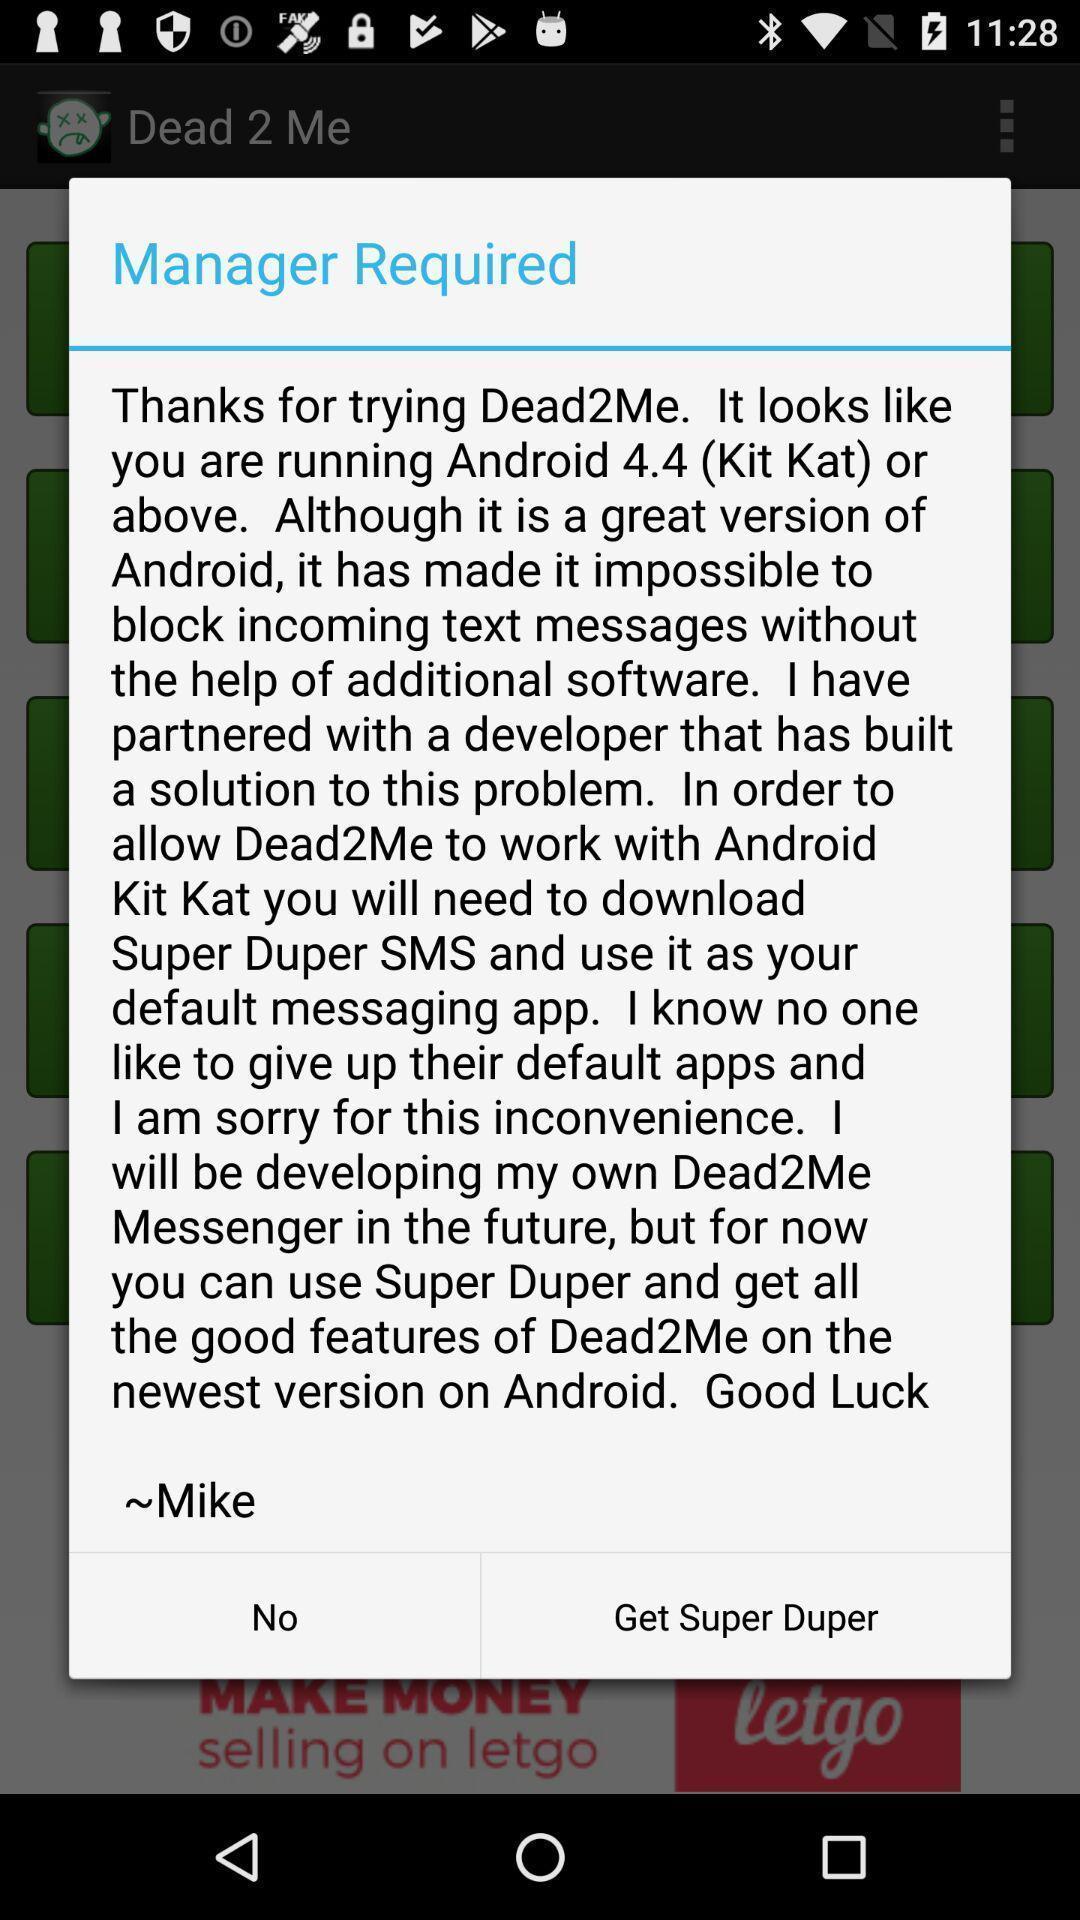Provide a description of this screenshot. Popup showing versions. 